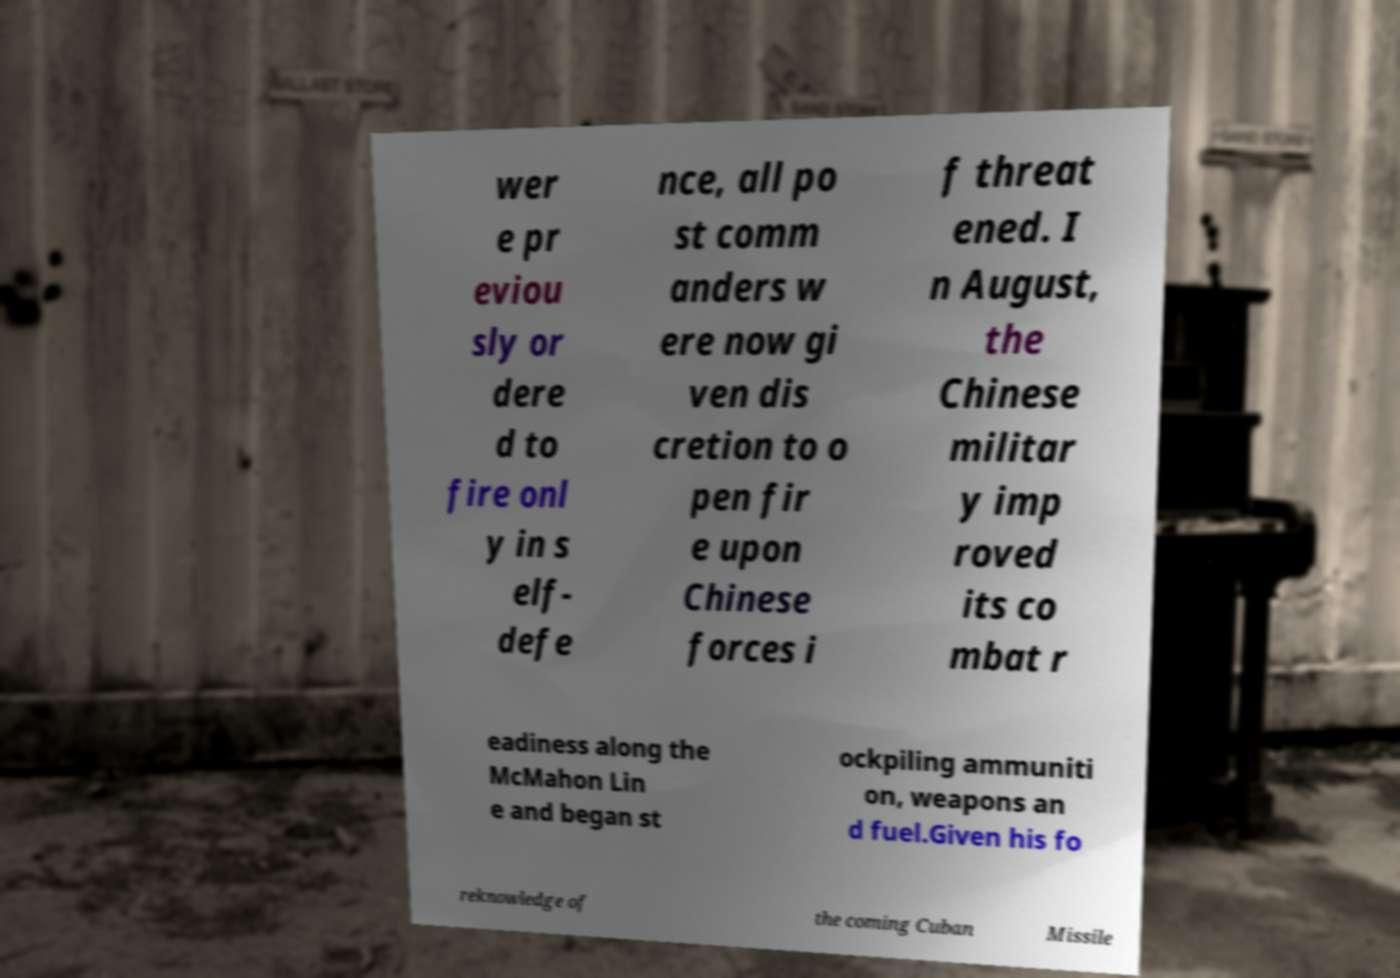Please read and relay the text visible in this image. What does it say? wer e pr eviou sly or dere d to fire onl y in s elf- defe nce, all po st comm anders w ere now gi ven dis cretion to o pen fir e upon Chinese forces i f threat ened. I n August, the Chinese militar y imp roved its co mbat r eadiness along the McMahon Lin e and began st ockpiling ammuniti on, weapons an d fuel.Given his fo reknowledge of the coming Cuban Missile 